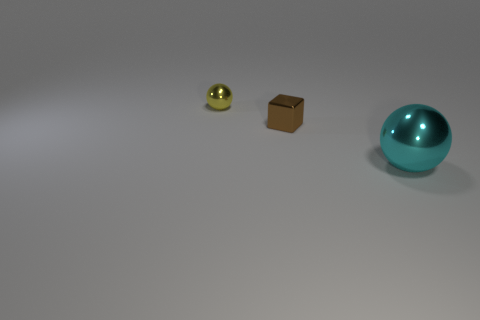Add 3 balls. How many objects exist? 6 Subtract all cyan balls. How many balls are left? 1 Subtract 1 balls. How many balls are left? 1 Subtract 0 cyan cubes. How many objects are left? 3 Subtract all spheres. How many objects are left? 1 Subtract all blue balls. Subtract all gray cubes. How many balls are left? 2 Subtract all brown objects. Subtract all large cyan metallic spheres. How many objects are left? 1 Add 2 yellow things. How many yellow things are left? 3 Add 3 tiny yellow things. How many tiny yellow things exist? 4 